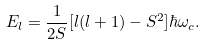Convert formula to latex. <formula><loc_0><loc_0><loc_500><loc_500>E _ { l } = \frac { 1 } { 2 S } [ l ( l + 1 ) - S ^ { 2 } ] \hbar { \omega } _ { c } .</formula> 